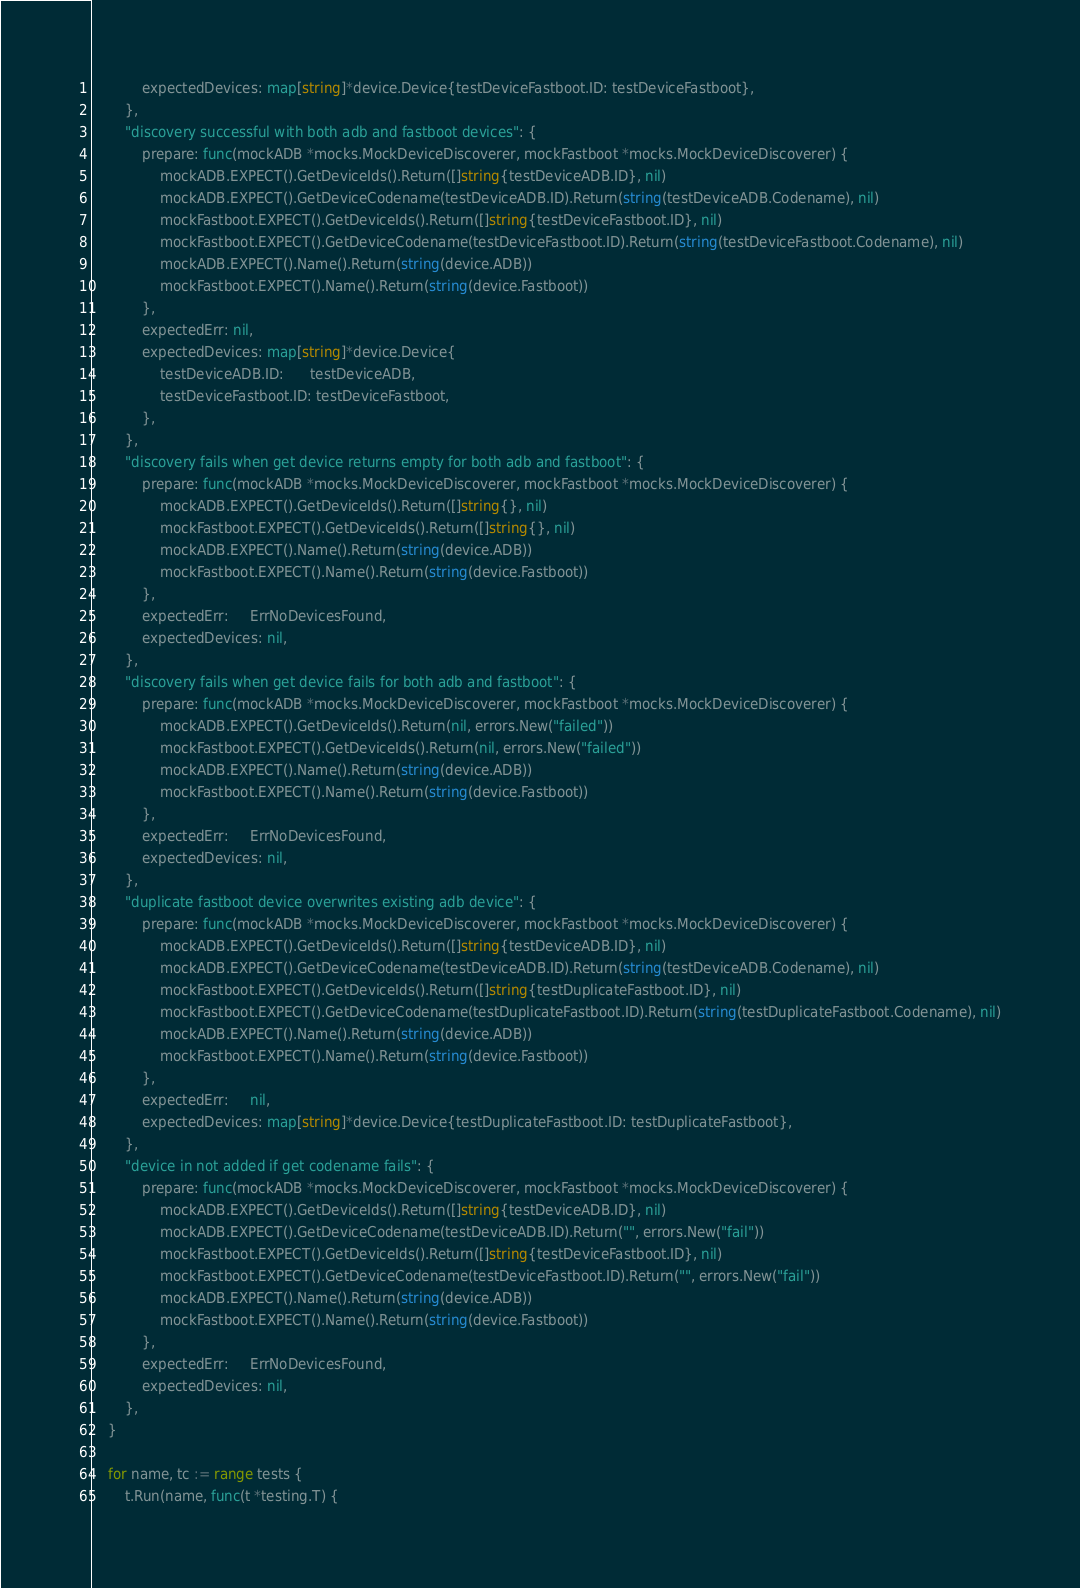Convert code to text. <code><loc_0><loc_0><loc_500><loc_500><_Go_>			expectedDevices: map[string]*device.Device{testDeviceFastboot.ID: testDeviceFastboot},
		},
		"discovery successful with both adb and fastboot devices": {
			prepare: func(mockADB *mocks.MockDeviceDiscoverer, mockFastboot *mocks.MockDeviceDiscoverer) {
				mockADB.EXPECT().GetDeviceIds().Return([]string{testDeviceADB.ID}, nil)
				mockADB.EXPECT().GetDeviceCodename(testDeviceADB.ID).Return(string(testDeviceADB.Codename), nil)
				mockFastboot.EXPECT().GetDeviceIds().Return([]string{testDeviceFastboot.ID}, nil)
				mockFastboot.EXPECT().GetDeviceCodename(testDeviceFastboot.ID).Return(string(testDeviceFastboot.Codename), nil)
				mockADB.EXPECT().Name().Return(string(device.ADB))
				mockFastboot.EXPECT().Name().Return(string(device.Fastboot))
			},
			expectedErr: nil,
			expectedDevices: map[string]*device.Device{
				testDeviceADB.ID:      testDeviceADB,
				testDeviceFastboot.ID: testDeviceFastboot,
			},
		},
		"discovery fails when get device returns empty for both adb and fastboot": {
			prepare: func(mockADB *mocks.MockDeviceDiscoverer, mockFastboot *mocks.MockDeviceDiscoverer) {
				mockADB.EXPECT().GetDeviceIds().Return([]string{}, nil)
				mockFastboot.EXPECT().GetDeviceIds().Return([]string{}, nil)
				mockADB.EXPECT().Name().Return(string(device.ADB))
				mockFastboot.EXPECT().Name().Return(string(device.Fastboot))
			},
			expectedErr:     ErrNoDevicesFound,
			expectedDevices: nil,
		},
		"discovery fails when get device fails for both adb and fastboot": {
			prepare: func(mockADB *mocks.MockDeviceDiscoverer, mockFastboot *mocks.MockDeviceDiscoverer) {
				mockADB.EXPECT().GetDeviceIds().Return(nil, errors.New("failed"))
				mockFastboot.EXPECT().GetDeviceIds().Return(nil, errors.New("failed"))
				mockADB.EXPECT().Name().Return(string(device.ADB))
				mockFastboot.EXPECT().Name().Return(string(device.Fastboot))
			},
			expectedErr:     ErrNoDevicesFound,
			expectedDevices: nil,
		},
		"duplicate fastboot device overwrites existing adb device": {
			prepare: func(mockADB *mocks.MockDeviceDiscoverer, mockFastboot *mocks.MockDeviceDiscoverer) {
				mockADB.EXPECT().GetDeviceIds().Return([]string{testDeviceADB.ID}, nil)
				mockADB.EXPECT().GetDeviceCodename(testDeviceADB.ID).Return(string(testDeviceADB.Codename), nil)
				mockFastboot.EXPECT().GetDeviceIds().Return([]string{testDuplicateFastboot.ID}, nil)
				mockFastboot.EXPECT().GetDeviceCodename(testDuplicateFastboot.ID).Return(string(testDuplicateFastboot.Codename), nil)
				mockADB.EXPECT().Name().Return(string(device.ADB))
				mockFastboot.EXPECT().Name().Return(string(device.Fastboot))
			},
			expectedErr:     nil,
			expectedDevices: map[string]*device.Device{testDuplicateFastboot.ID: testDuplicateFastboot},
		},
		"device in not added if get codename fails": {
			prepare: func(mockADB *mocks.MockDeviceDiscoverer, mockFastboot *mocks.MockDeviceDiscoverer) {
				mockADB.EXPECT().GetDeviceIds().Return([]string{testDeviceADB.ID}, nil)
				mockADB.EXPECT().GetDeviceCodename(testDeviceADB.ID).Return("", errors.New("fail"))
				mockFastboot.EXPECT().GetDeviceIds().Return([]string{testDeviceFastboot.ID}, nil)
				mockFastboot.EXPECT().GetDeviceCodename(testDeviceFastboot.ID).Return("", errors.New("fail"))
				mockADB.EXPECT().Name().Return(string(device.ADB))
				mockFastboot.EXPECT().Name().Return(string(device.Fastboot))
			},
			expectedErr:     ErrNoDevicesFound,
			expectedDevices: nil,
		},
	}

	for name, tc := range tests {
		t.Run(name, func(t *testing.T) {</code> 